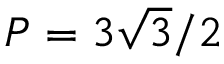Convert formula to latex. <formula><loc_0><loc_0><loc_500><loc_500>P = 3 \sqrt { 3 } / 2</formula> 